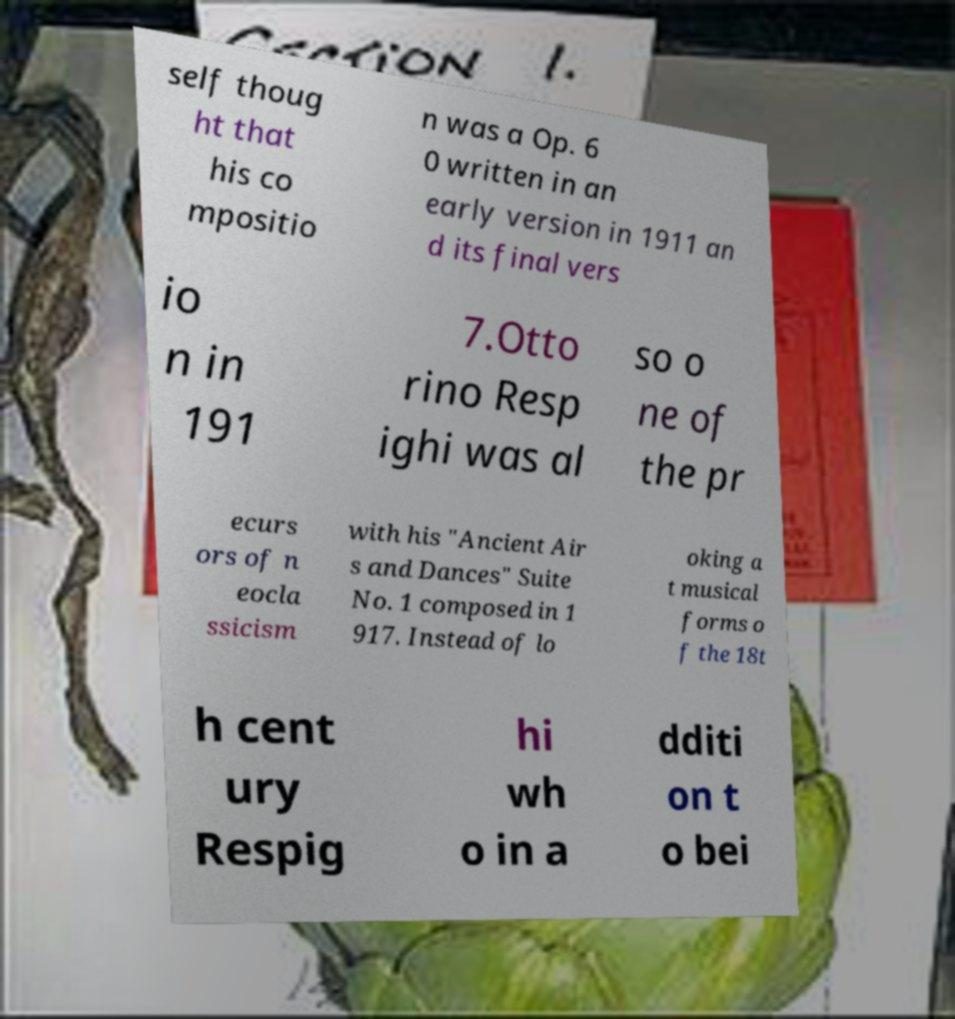Could you extract and type out the text from this image? self thoug ht that his co mpositio n was a Op. 6 0 written in an early version in 1911 an d its final vers io n in 191 7.Otto rino Resp ighi was al so o ne of the pr ecurs ors of n eocla ssicism with his "Ancient Air s and Dances" Suite No. 1 composed in 1 917. Instead of lo oking a t musical forms o f the 18t h cent ury Respig hi wh o in a dditi on t o bei 